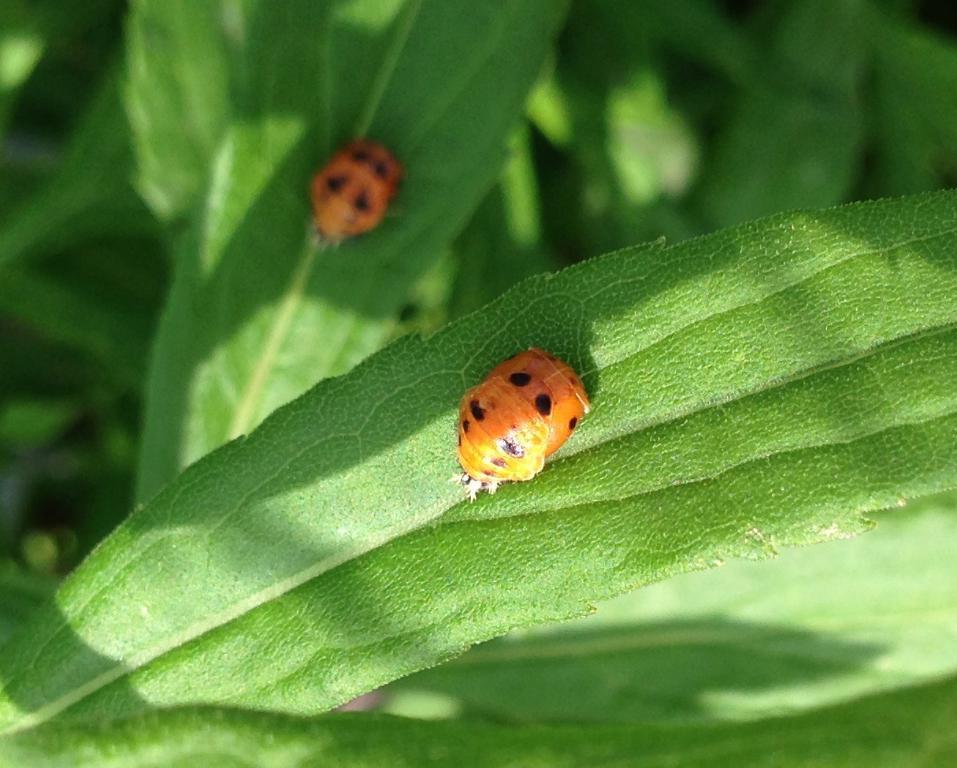In one or two sentences, can you explain what this image depicts? In this picture we can see the insects on the leaves. 